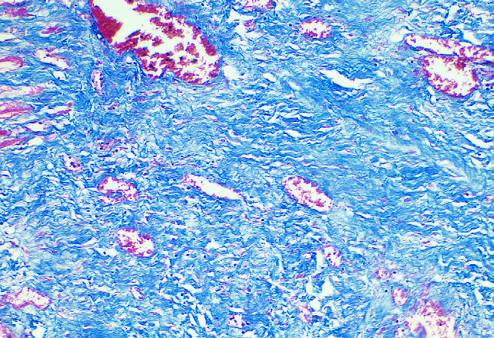what is stained blue by the trichrome stain?
Answer the question using a single word or phrase. Collagen 